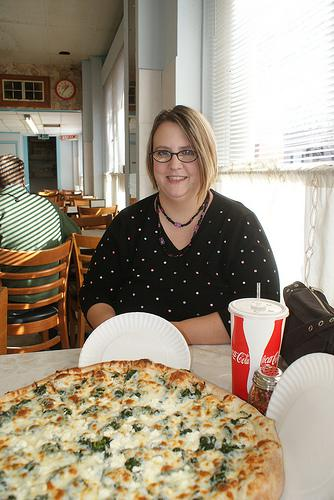Question: what type of food is on the table?
Choices:
A. Calzones.
B. Pizza.
C. Sandwiches.
D. Seafood.
Answer with the letter. Answer: B Question: what drink is advertised on the cup?
Choices:
A. Coca-Cola.
B. Mountain Dew.
C. Sprite.
D. Pepsi.
Answer with the letter. Answer: A Question: where is the lady's purse?
Choices:
A. On the table.
B. On the floor.
C. On the desk.
D. On the seat.
Answer with the letter. Answer: A Question: what is the woman wearing on her face?
Choices:
A. Nose ring.
B. Brow piercing.
C. Eyeglasses.
D. Lip piercing.
Answer with the letter. Answer: C Question: what is around the woman's neck?
Choices:
A. Ribbons.
B. Beads.
C. Eyeglass holder.
D. Necklaces.
Answer with the letter. Answer: D Question: how many people are visible?
Choices:
A. 1.
B. 3.
C. 4.
D. 2.
Answer with the letter. Answer: D 